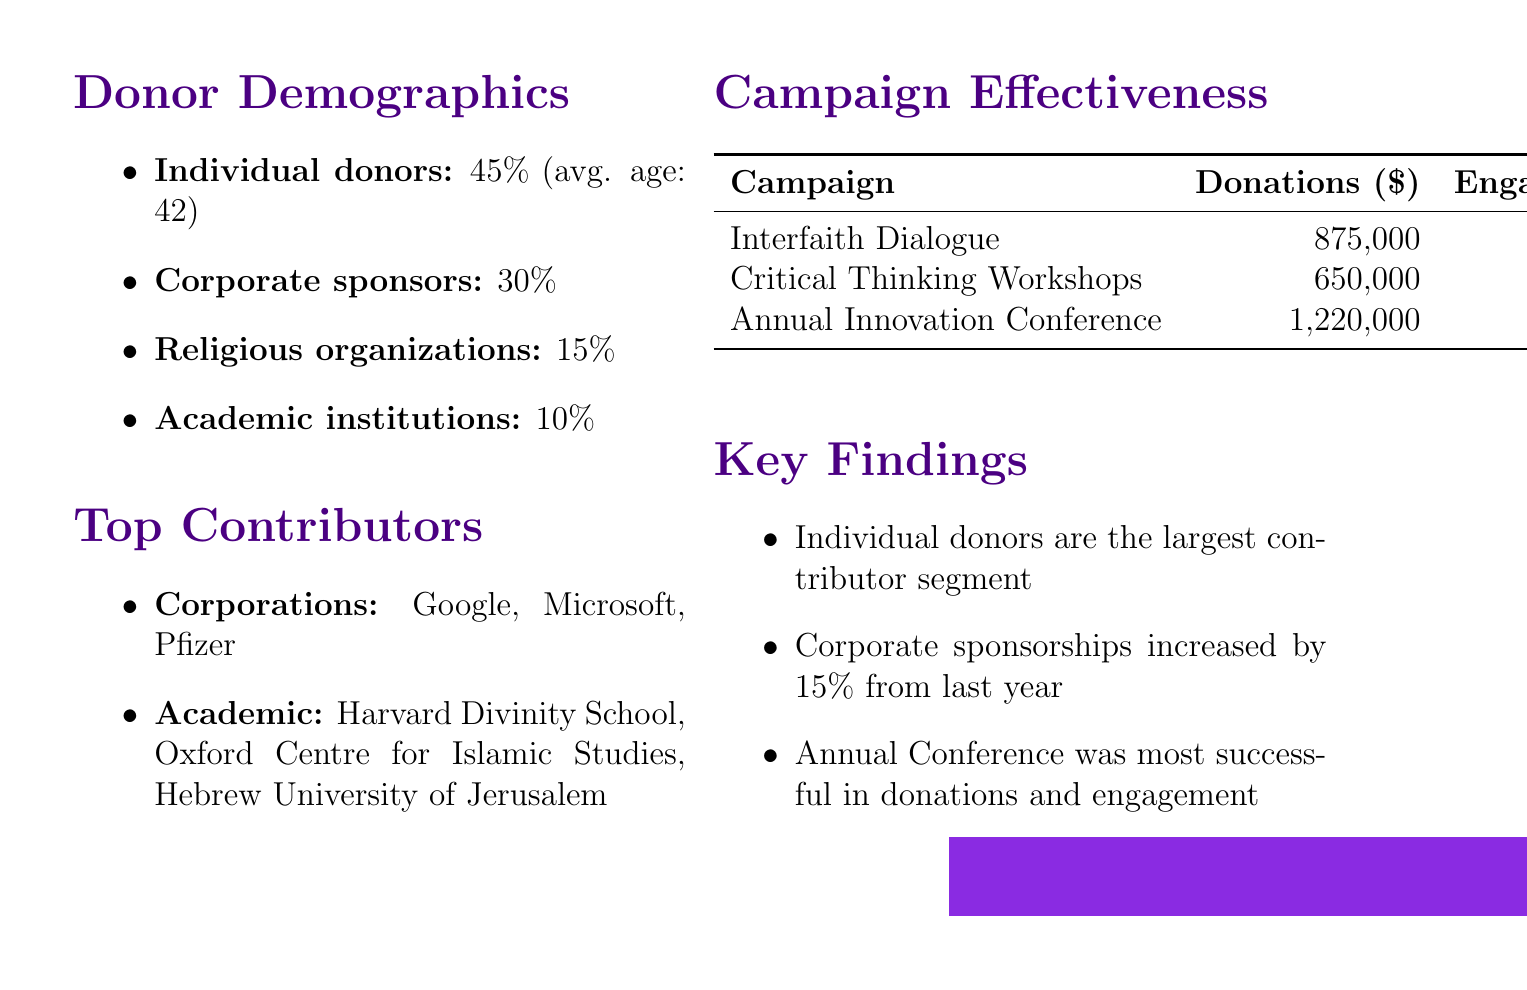What is the total donations received by the foundation? The total donations are explicitly stated in the document as $2,745,000.
Answer: $2,745,000 What percentage of donations come from individual donors? The document states that individual donors constitute 45% of the donations.
Answer: 45% Which campaign generated the highest amount of donations? The document indicates that the Annual Theological Innovation Conference received $1,220,000, making it the highest.
Answer: Annual Theological Innovation Conference What is the average age of individual donors? The document provides the average age of individual donors as 42.
Answer: 42 What was the participant engagement percentage for the Interfaith Dialogue Series campaign? The document notes that the participant engagement for this campaign was 92%.
Answer: 92% Which demographic category makes up 30% of the donations? The document categorizes corporate sponsors as making up 30% of the donations.
Answer: Corporate sponsors Identify one notable company that sponsored the foundation. The document lists Google, Microsoft, and Pfizer as notable companies supporting the foundation.
Answer: Google What is the cost-effectiveness ratio of the Critical Thinking in Theology Workshops? This information is provided in the document, stating the ratio is 0.78.
Answer: 0.78 Name one top contributor from the academic institutions category. The document mentions Harvard Divinity School, Oxford Centre for Islamic Studies, and Hebrew University of Jerusalem as top contributors.
Answer: Harvard Divinity School 